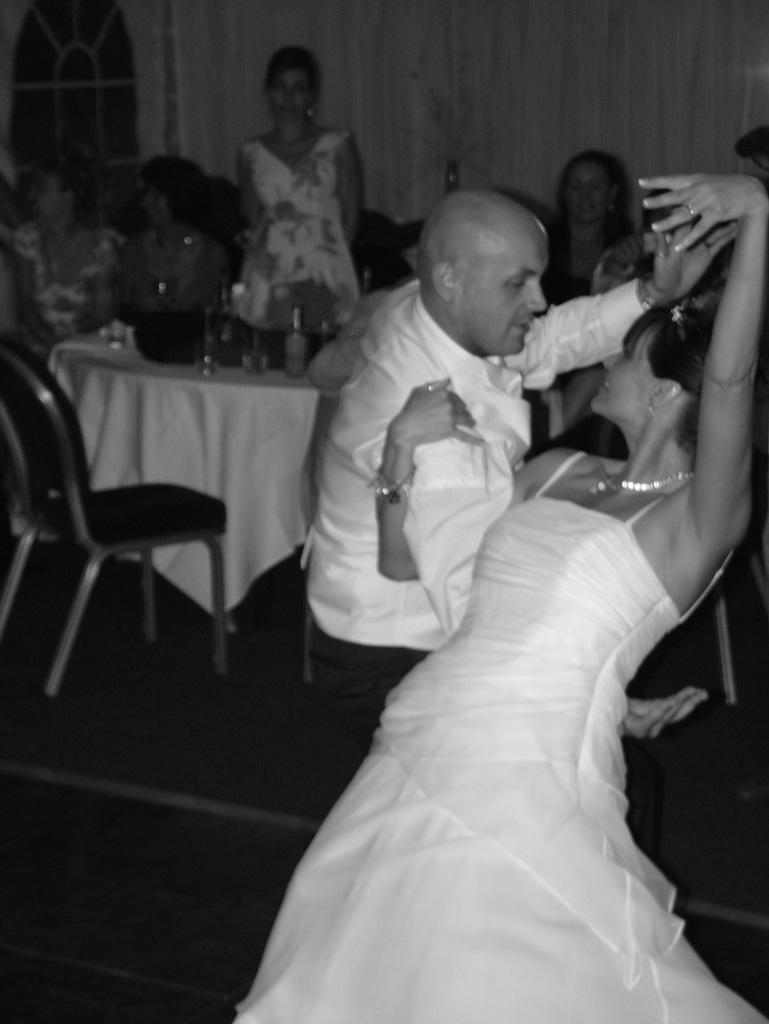Describe this image in one or two sentences. In this picture, we see man in white dress and woman in white dress are dancing. Behind them, we see a table on which glass bottle and glass are placed and there, we see two women sitting on chair. Behind them, we see a white wall. 